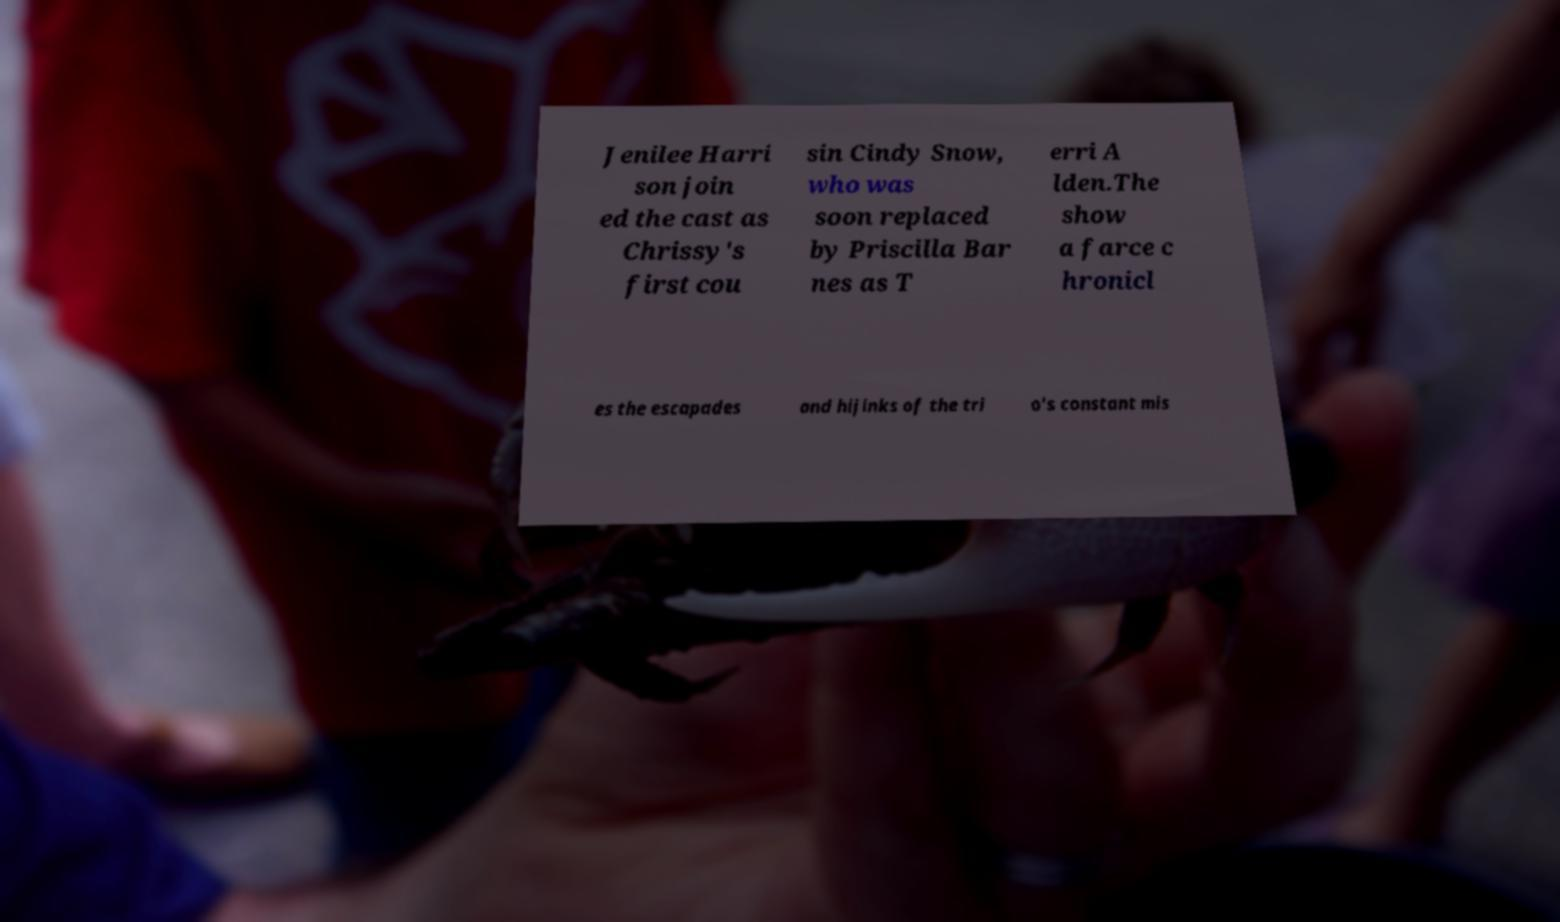There's text embedded in this image that I need extracted. Can you transcribe it verbatim? Jenilee Harri son join ed the cast as Chrissy's first cou sin Cindy Snow, who was soon replaced by Priscilla Bar nes as T erri A lden.The show a farce c hronicl es the escapades and hijinks of the tri o's constant mis 